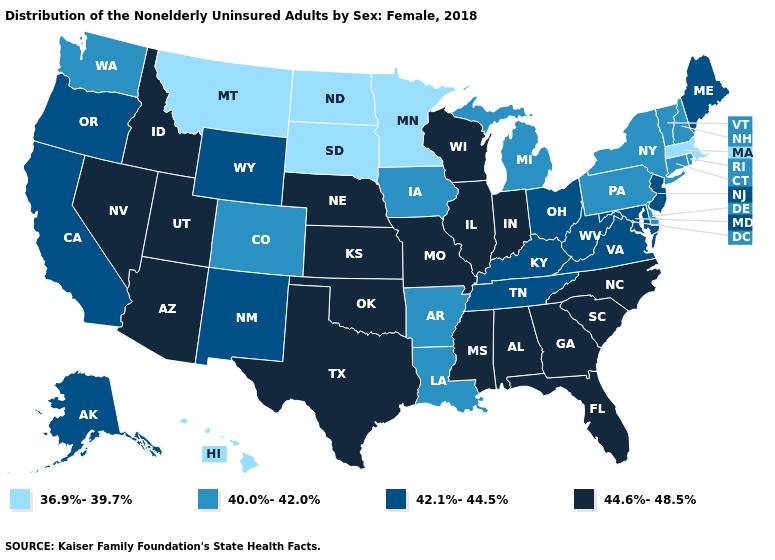Name the states that have a value in the range 40.0%-42.0%?
Write a very short answer. Arkansas, Colorado, Connecticut, Delaware, Iowa, Louisiana, Michigan, New Hampshire, New York, Pennsylvania, Rhode Island, Vermont, Washington. What is the lowest value in the Northeast?
Quick response, please. 36.9%-39.7%. What is the value of Utah?
Keep it brief. 44.6%-48.5%. How many symbols are there in the legend?
Give a very brief answer. 4. Does Rhode Island have the lowest value in the Northeast?
Keep it brief. No. What is the value of Wisconsin?
Short answer required. 44.6%-48.5%. Name the states that have a value in the range 44.6%-48.5%?
Short answer required. Alabama, Arizona, Florida, Georgia, Idaho, Illinois, Indiana, Kansas, Mississippi, Missouri, Nebraska, Nevada, North Carolina, Oklahoma, South Carolina, Texas, Utah, Wisconsin. Name the states that have a value in the range 40.0%-42.0%?
Short answer required. Arkansas, Colorado, Connecticut, Delaware, Iowa, Louisiana, Michigan, New Hampshire, New York, Pennsylvania, Rhode Island, Vermont, Washington. What is the value of Minnesota?
Short answer required. 36.9%-39.7%. What is the lowest value in the Northeast?
Keep it brief. 36.9%-39.7%. What is the lowest value in states that border Mississippi?
Be succinct. 40.0%-42.0%. What is the value of Utah?
Answer briefly. 44.6%-48.5%. Does New Jersey have the lowest value in the USA?
Quick response, please. No. What is the highest value in states that border Pennsylvania?
Give a very brief answer. 42.1%-44.5%. Does the first symbol in the legend represent the smallest category?
Quick response, please. Yes. 